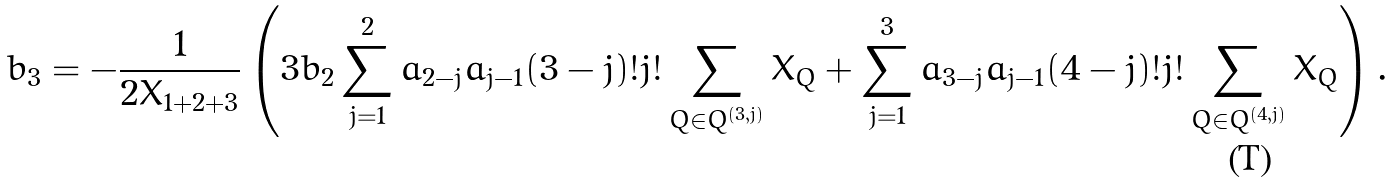Convert formula to latex. <formula><loc_0><loc_0><loc_500><loc_500>b _ { 3 } & = - \frac { 1 } { 2 X _ { 1 + 2 + 3 } } \left ( 3 b _ { 2 } \sum _ { j = 1 } ^ { 2 } a _ { 2 - j } a _ { j - 1 } ( 3 - j ) ! j ! \sum _ { Q \in Q ^ { ( 3 , j ) } } X _ { Q } + \sum _ { j = 1 } ^ { 3 } a _ { 3 - j } a _ { j - 1 } ( 4 - j ) ! j ! \sum _ { Q \in Q ^ { ( 4 , j ) } } X _ { Q } \right ) .</formula> 